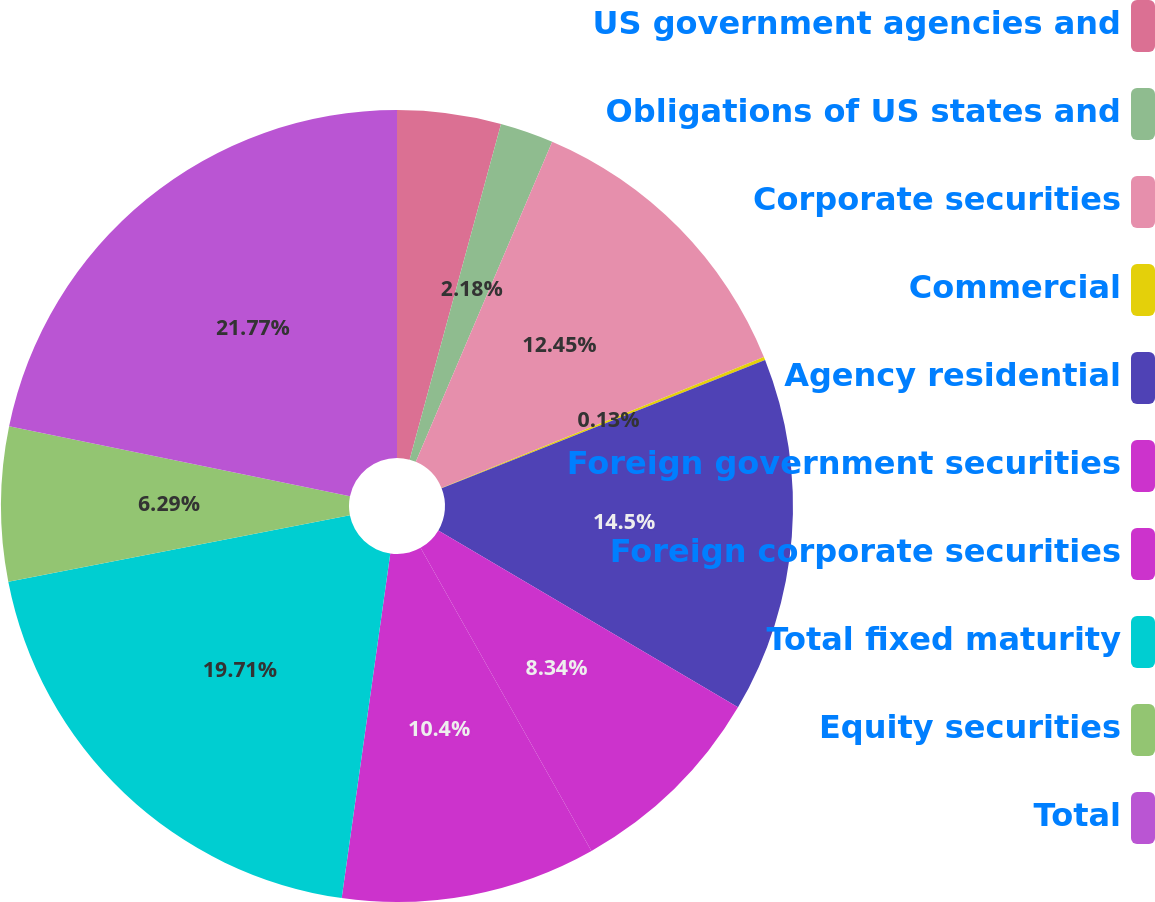Convert chart. <chart><loc_0><loc_0><loc_500><loc_500><pie_chart><fcel>US government agencies and<fcel>Obligations of US states and<fcel>Corporate securities<fcel>Commercial<fcel>Agency residential<fcel>Foreign government securities<fcel>Foreign corporate securities<fcel>Total fixed maturity<fcel>Equity securities<fcel>Total<nl><fcel>4.23%<fcel>2.18%<fcel>12.45%<fcel>0.13%<fcel>14.5%<fcel>8.34%<fcel>10.4%<fcel>19.71%<fcel>6.29%<fcel>21.77%<nl></chart> 